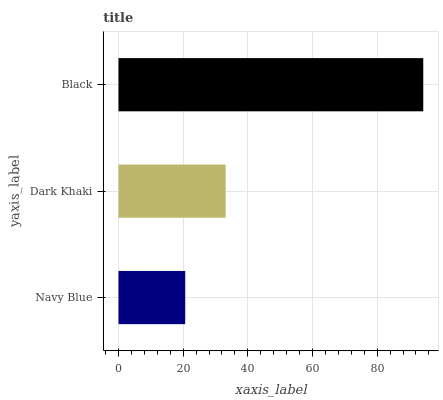Is Navy Blue the minimum?
Answer yes or no. Yes. Is Black the maximum?
Answer yes or no. Yes. Is Dark Khaki the minimum?
Answer yes or no. No. Is Dark Khaki the maximum?
Answer yes or no. No. Is Dark Khaki greater than Navy Blue?
Answer yes or no. Yes. Is Navy Blue less than Dark Khaki?
Answer yes or no. Yes. Is Navy Blue greater than Dark Khaki?
Answer yes or no. No. Is Dark Khaki less than Navy Blue?
Answer yes or no. No. Is Dark Khaki the high median?
Answer yes or no. Yes. Is Dark Khaki the low median?
Answer yes or no. Yes. Is Black the high median?
Answer yes or no. No. Is Navy Blue the low median?
Answer yes or no. No. 